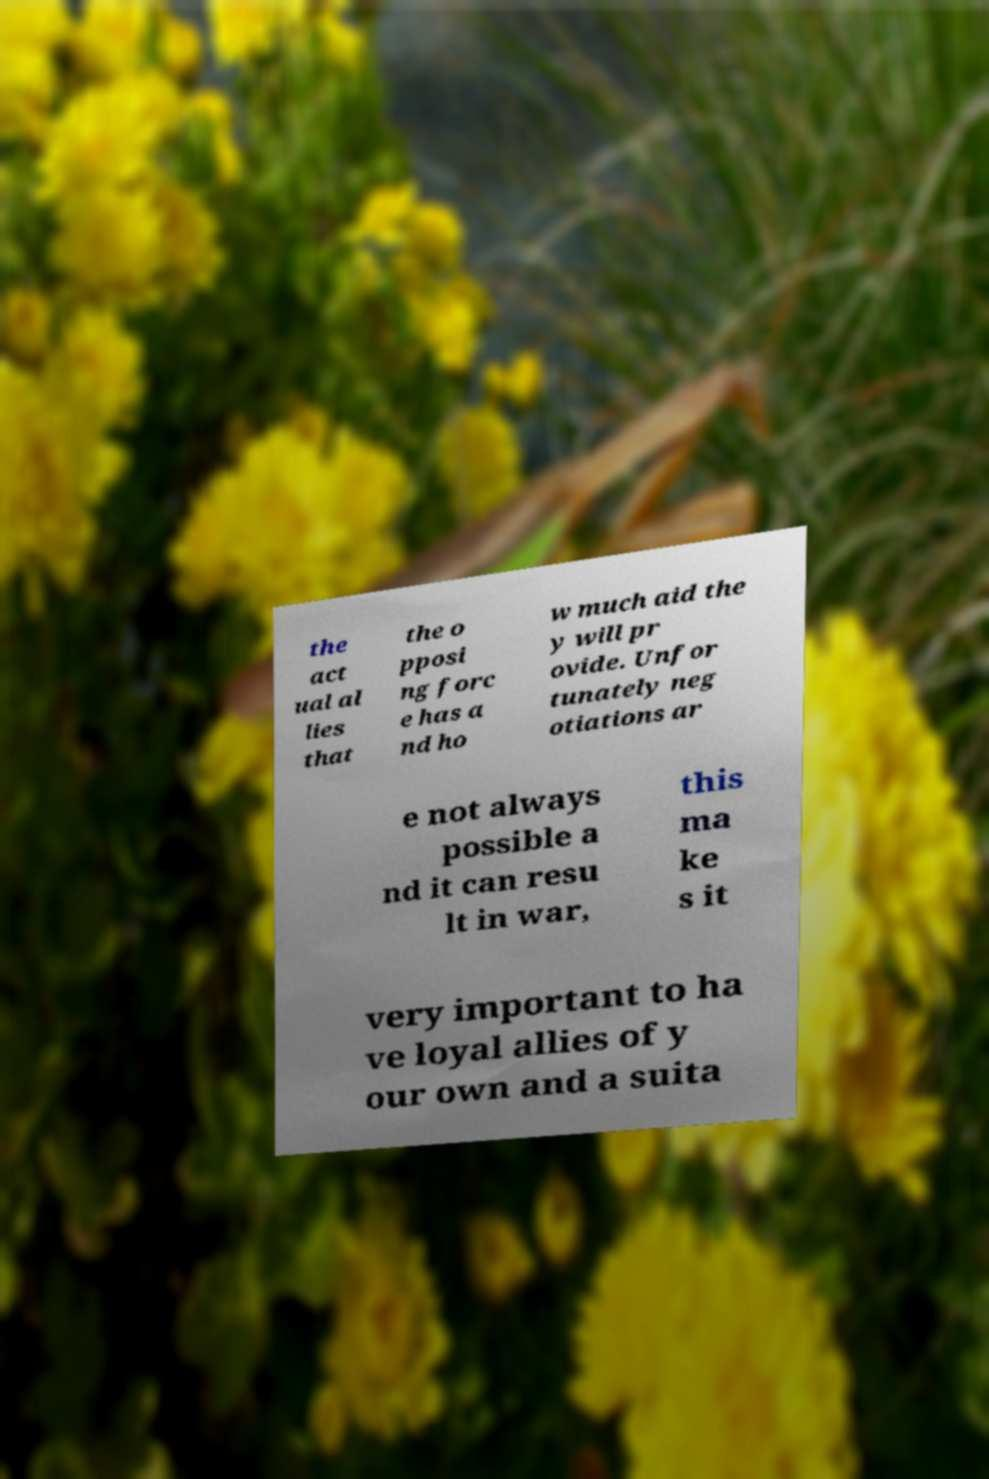Please read and relay the text visible in this image. What does it say? the act ual al lies that the o pposi ng forc e has a nd ho w much aid the y will pr ovide. Unfor tunately neg otiations ar e not always possible a nd it can resu lt in war, this ma ke s it very important to ha ve loyal allies of y our own and a suita 